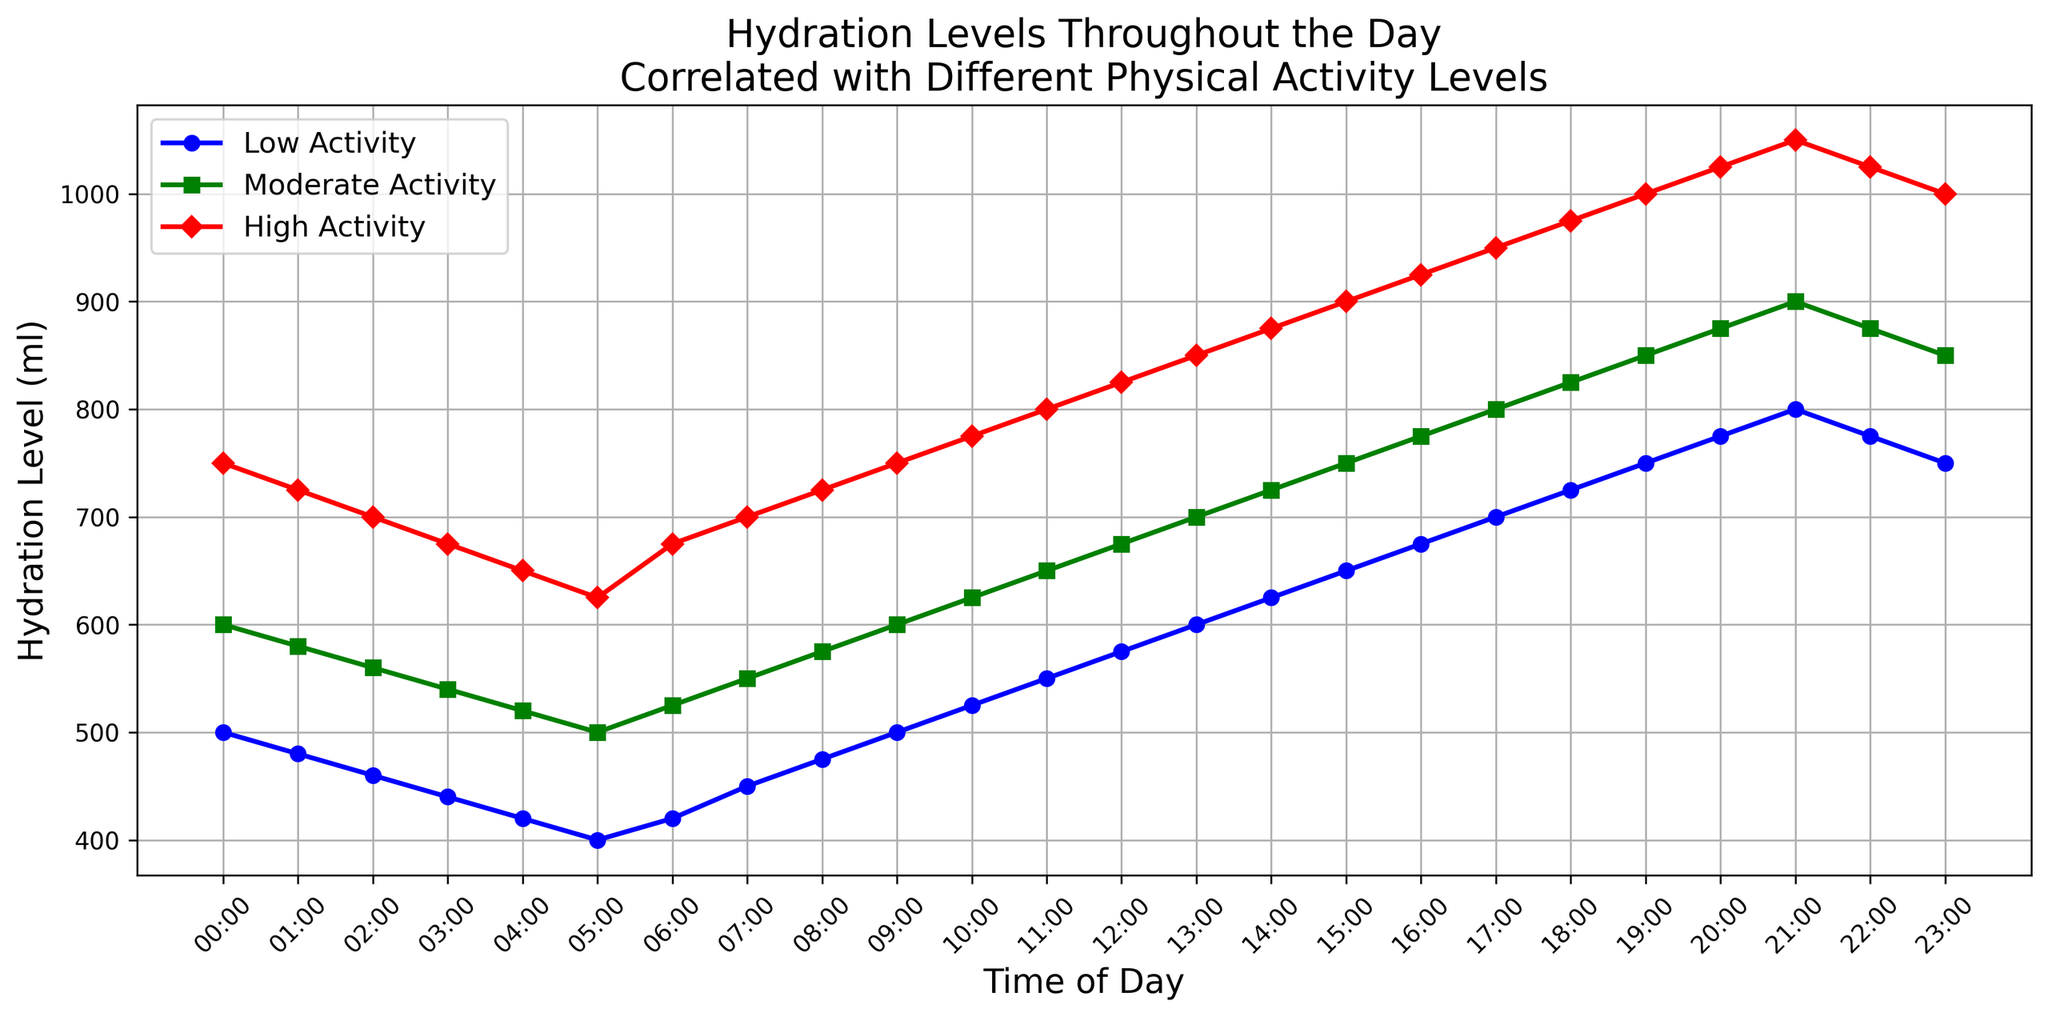What time of day has the lowest hydration levels for each activity level? To find the lowest hydration levels, we will look for the minimum values on each line: 
- Low Activity: The lowest point is 400 ml at 05:00.
- Moderate Activity: The lowest point is 500 ml at 05:00.
- High Activity: The lowest point is 625 ml at 05:00.
Answer: 05:00 Which activity level shows the highest hydration level and at what time? To find the highest hydration level, look for the highest peak:
- High Activity has the highest value of 1050 ml at 21:00.
Answer: High Activity, 21:00 At what time do all activity levels have the same hydration pattern? We are looking for points on the graph where the lines follow a similar pattern:
- All three activity lines, although at different levels, start increasing and reach their respective peaks around 21:00–19:00.
Answer: 21:00–19:00 How much more hydration is needed for high activity compared to low activity at 14:00? Look at the hydration levels at 14:00:
- High Activity: 875 ml
- Low Activity: 625 ml
- Difference: 875 - 625 = 250 ml
Answer: 250 ml What is the average hydration level for moderate activity between 12:00 and 16:00? To calculate the average hydration level:
- Values: 675, 700, 725, 750, 775 ml
- Sum: 675 + 700 + 725 + 750 + 775 = 3625 ml
- Average: 3625 / 5 = 725 ml
Answer: 725 ml How does the hydration level for low activity change from 05:00 to 06:00? Look at the hydration levels at the specified times:
- 05:00: 400 ml
- 06:00: 420 ml
- Change: 420 - 400 = +20 ml
Answer: +20 ml During which hours does moderate activity hydration level exceed 800 ml? Check the data points where moderate activity hydration is above 800 ml:
- This happens between 17:00 and 22:00.
Answer: 17:00–22:00 Which activity level experiences the steepest increase in hydration level between 10:00 and 14:00? Calculate the differences between 10:00 and 14:00:
- Low Activity: 625 - 525 = 100 ml
- Moderate Activity: 725 - 625 = 100 ml
- High Activity: 875 - 775 = 100 ml
All activity levels have the same increase of 100 ml.
Answer: All activity levels At 18:00, by how much does the hydration level for high activity exceed that of moderate activity? Check the hydration levels at 18:00:
- High Activity: 975 ml
- Moderate Activity: 825 ml
- Difference: 975 - 825 = 150 ml
Answer: 150 ml What is the overall trend in hydration levels across all activities throughout the day? Observe the overall flow of the lines:
- Hydration levels decrease during early morning hours and increase substantially throughout the day, reaching peaks in the evening.
The trend is downward in the morning and then upward toward the evening.
Answer: Decrease in the morning, increase toward the evening 